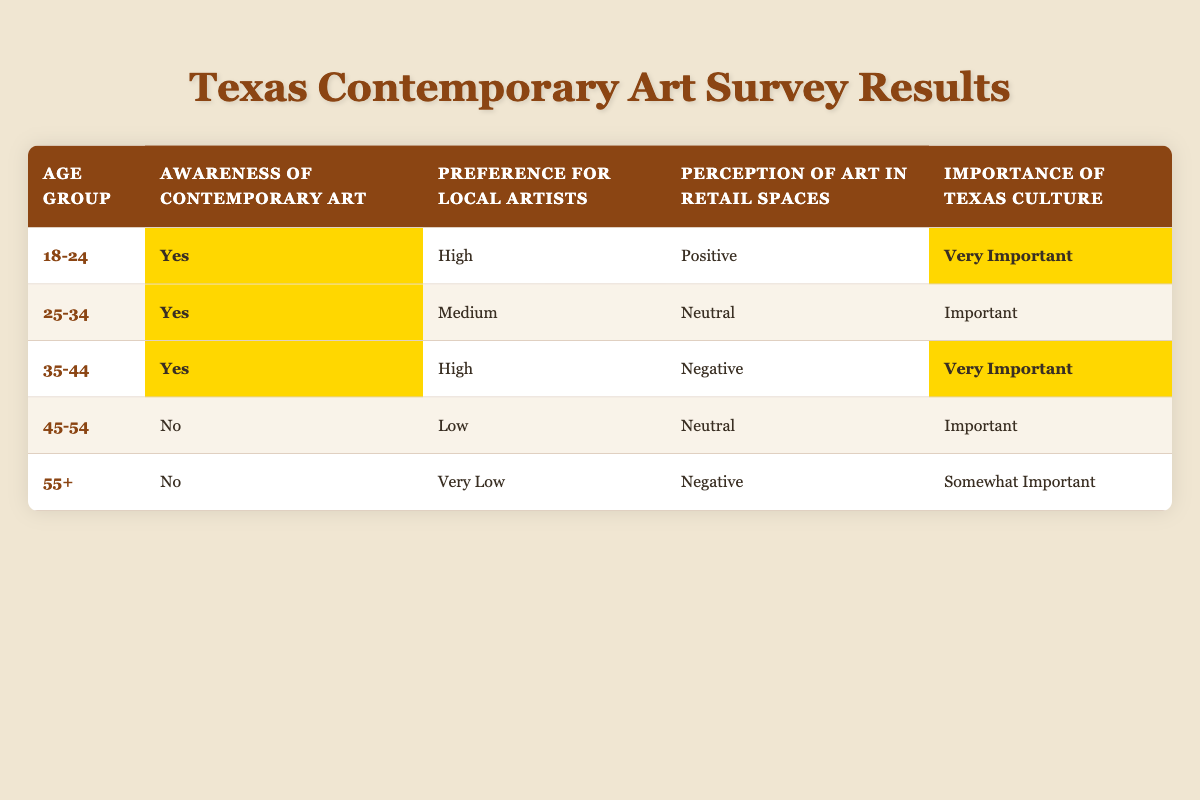What percentage of respondents aged 45-54 are aware of contemporary art? There are 5 age groups in the table. The group aged 45-54 has "No" under awareness of contemporary art. Since there's only one response for that age group, the percentage aware is 0%.
Answer: 0% What is the preference for local artists among those aged 18-24? The table shows that respondents in the 18-24 age group have a "High" preference for local artists.
Answer: High How many age groups have a "Very Important" perception of Texas culture? By examining the table, the age groups 18-24 and 35-44 have "Very Important" listed under the importance of Texas culture. Therefore, there are two age groups.
Answer: 2 Do respondents aged 55 and older prefer local artists? Under the preference for local artists, the age group of 55+ is classified as "Very Low." Thus, they do not exhibit a strong preference for local artists.
Answer: No What is the average preference for local artists across all age groups? Summarizing the preferences: High (3), Medium (1), Low (1), Very Low (1). To convert these into numerical values: High (3), Medium (2), Low (1), Very Low (0). The total is 3 + 2 + 1 + 0 = 6, with 5 data points. Average = 6/5 = 1.2. Therefore, the average preference level falls between Low and Medium.
Answer: Between Low and Medium How many respondents aged 25-34 have a neutral perception of art in retail spaces? The table indicates that only the 25-34 age group has "Neutral" under perception of art in retail spaces. Therefore, only the response for this age group reflects a neutral perception.
Answer: 1 Which age group has the highest preference for local artists? Analyzing the preferences, both the 18-24 and 35-44 age groups have a "High" preference for local artists. Therefore, the highest preference is "High," held by these two age groups.
Answer: 18-24 and 35-44 Is there a correlation between awareness of contemporary art and the importance of Texas culture for the age group 35-44? For the 35-44 age group, the awareness of contemporary art is "Yes" and the importance of Texas culture is "Very Important." This indicates a positive correlation between knowledge of contemporary art and valuing Texas culture.
Answer: Yes 